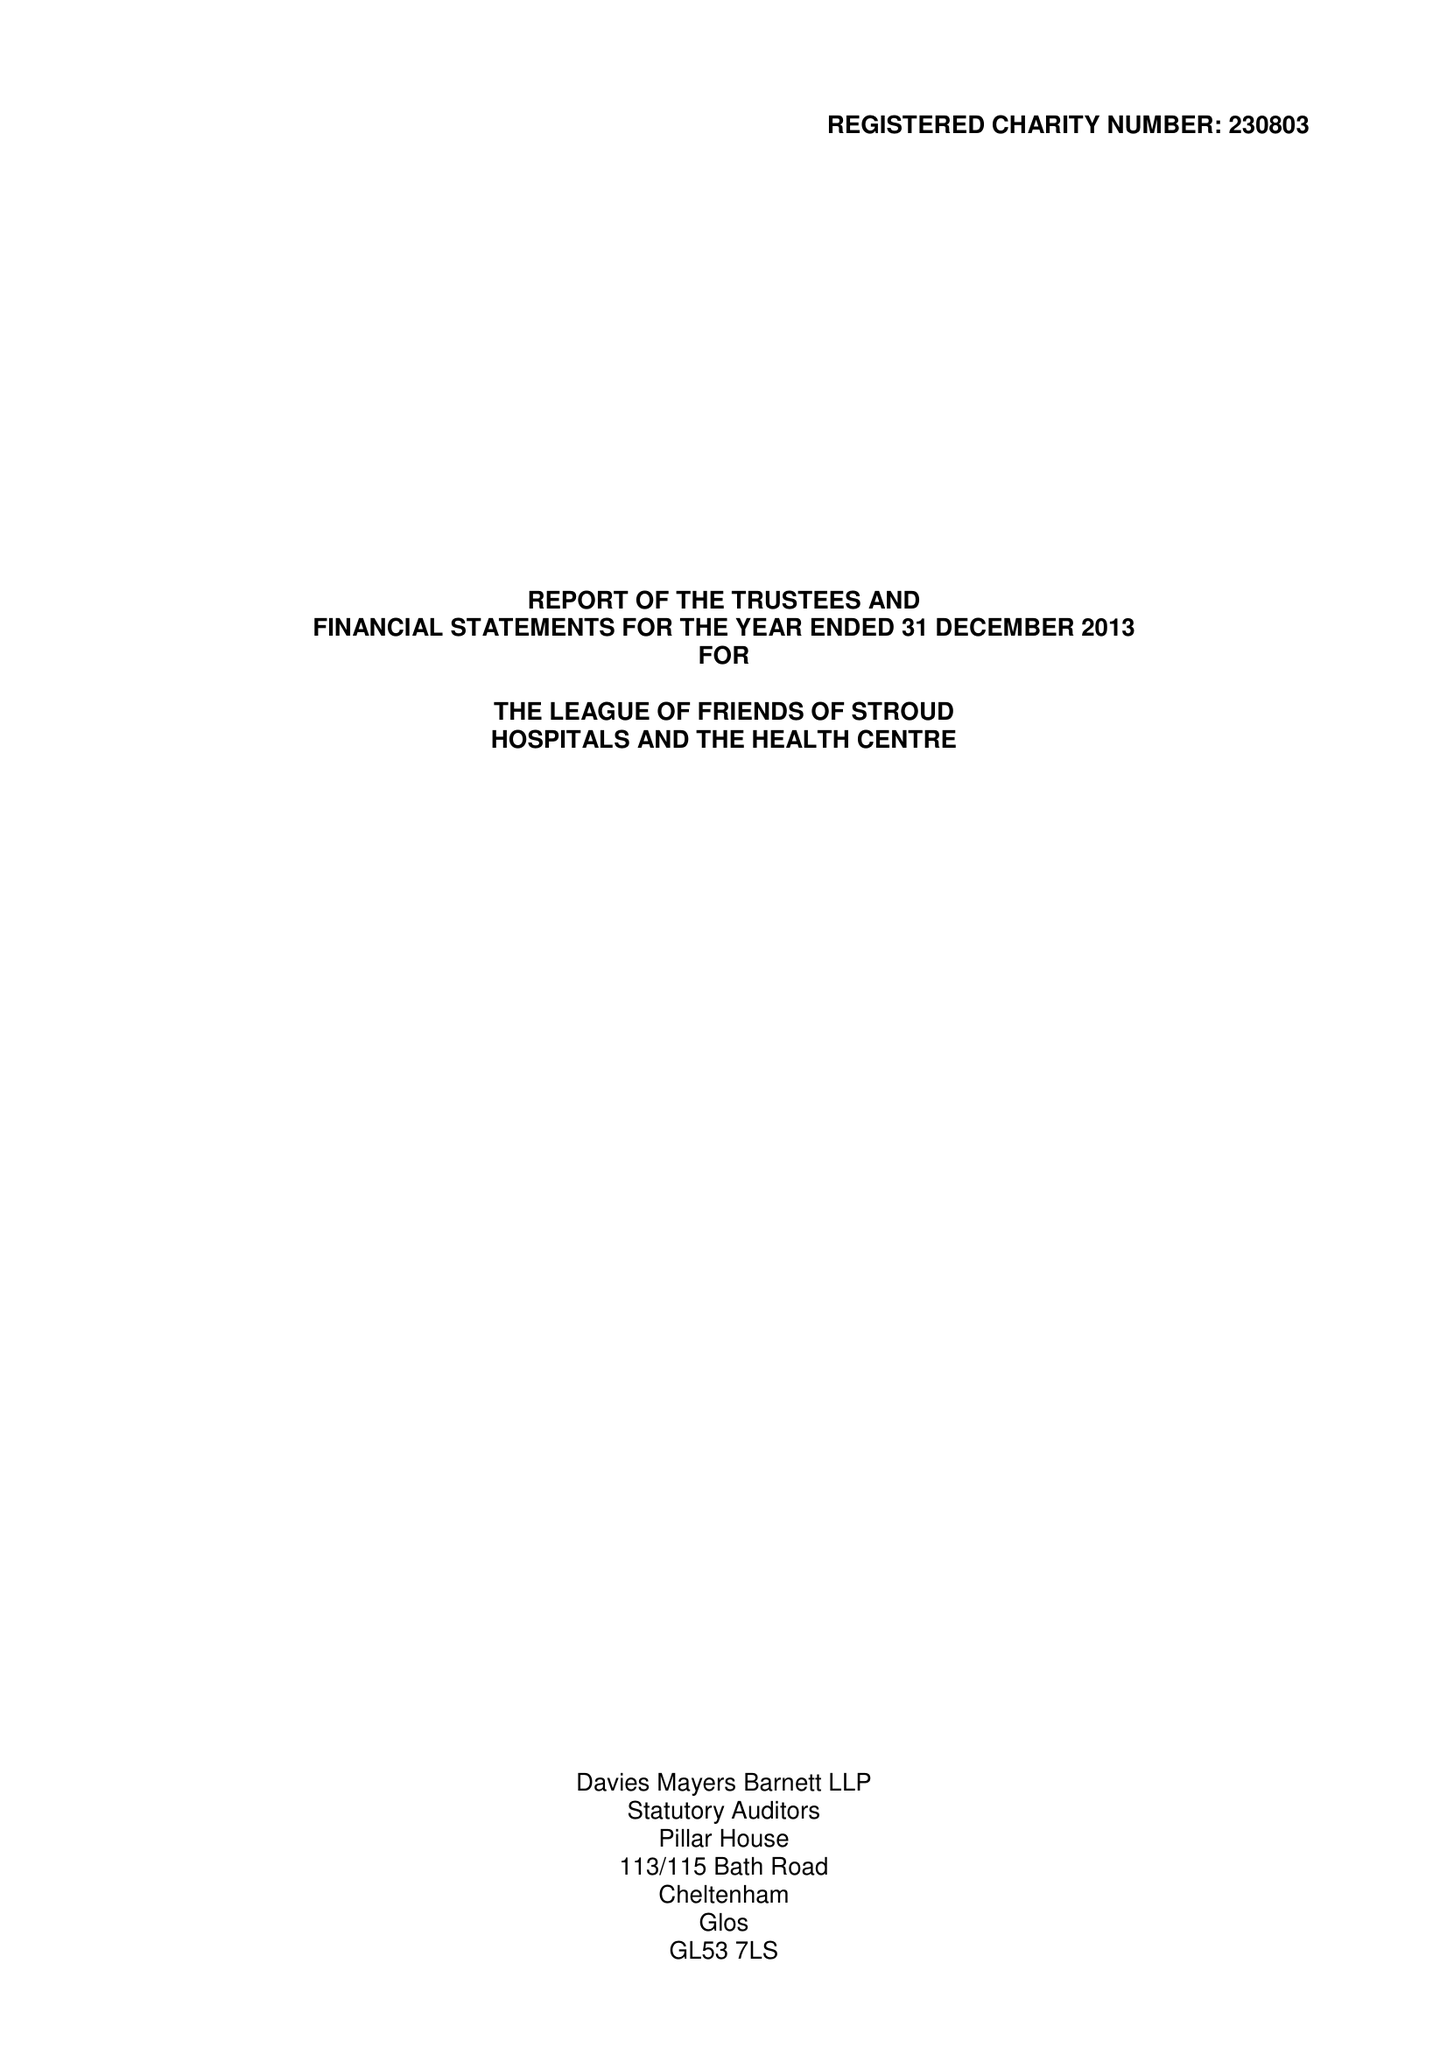What is the value for the report_date?
Answer the question using a single word or phrase. 2013-12-31 